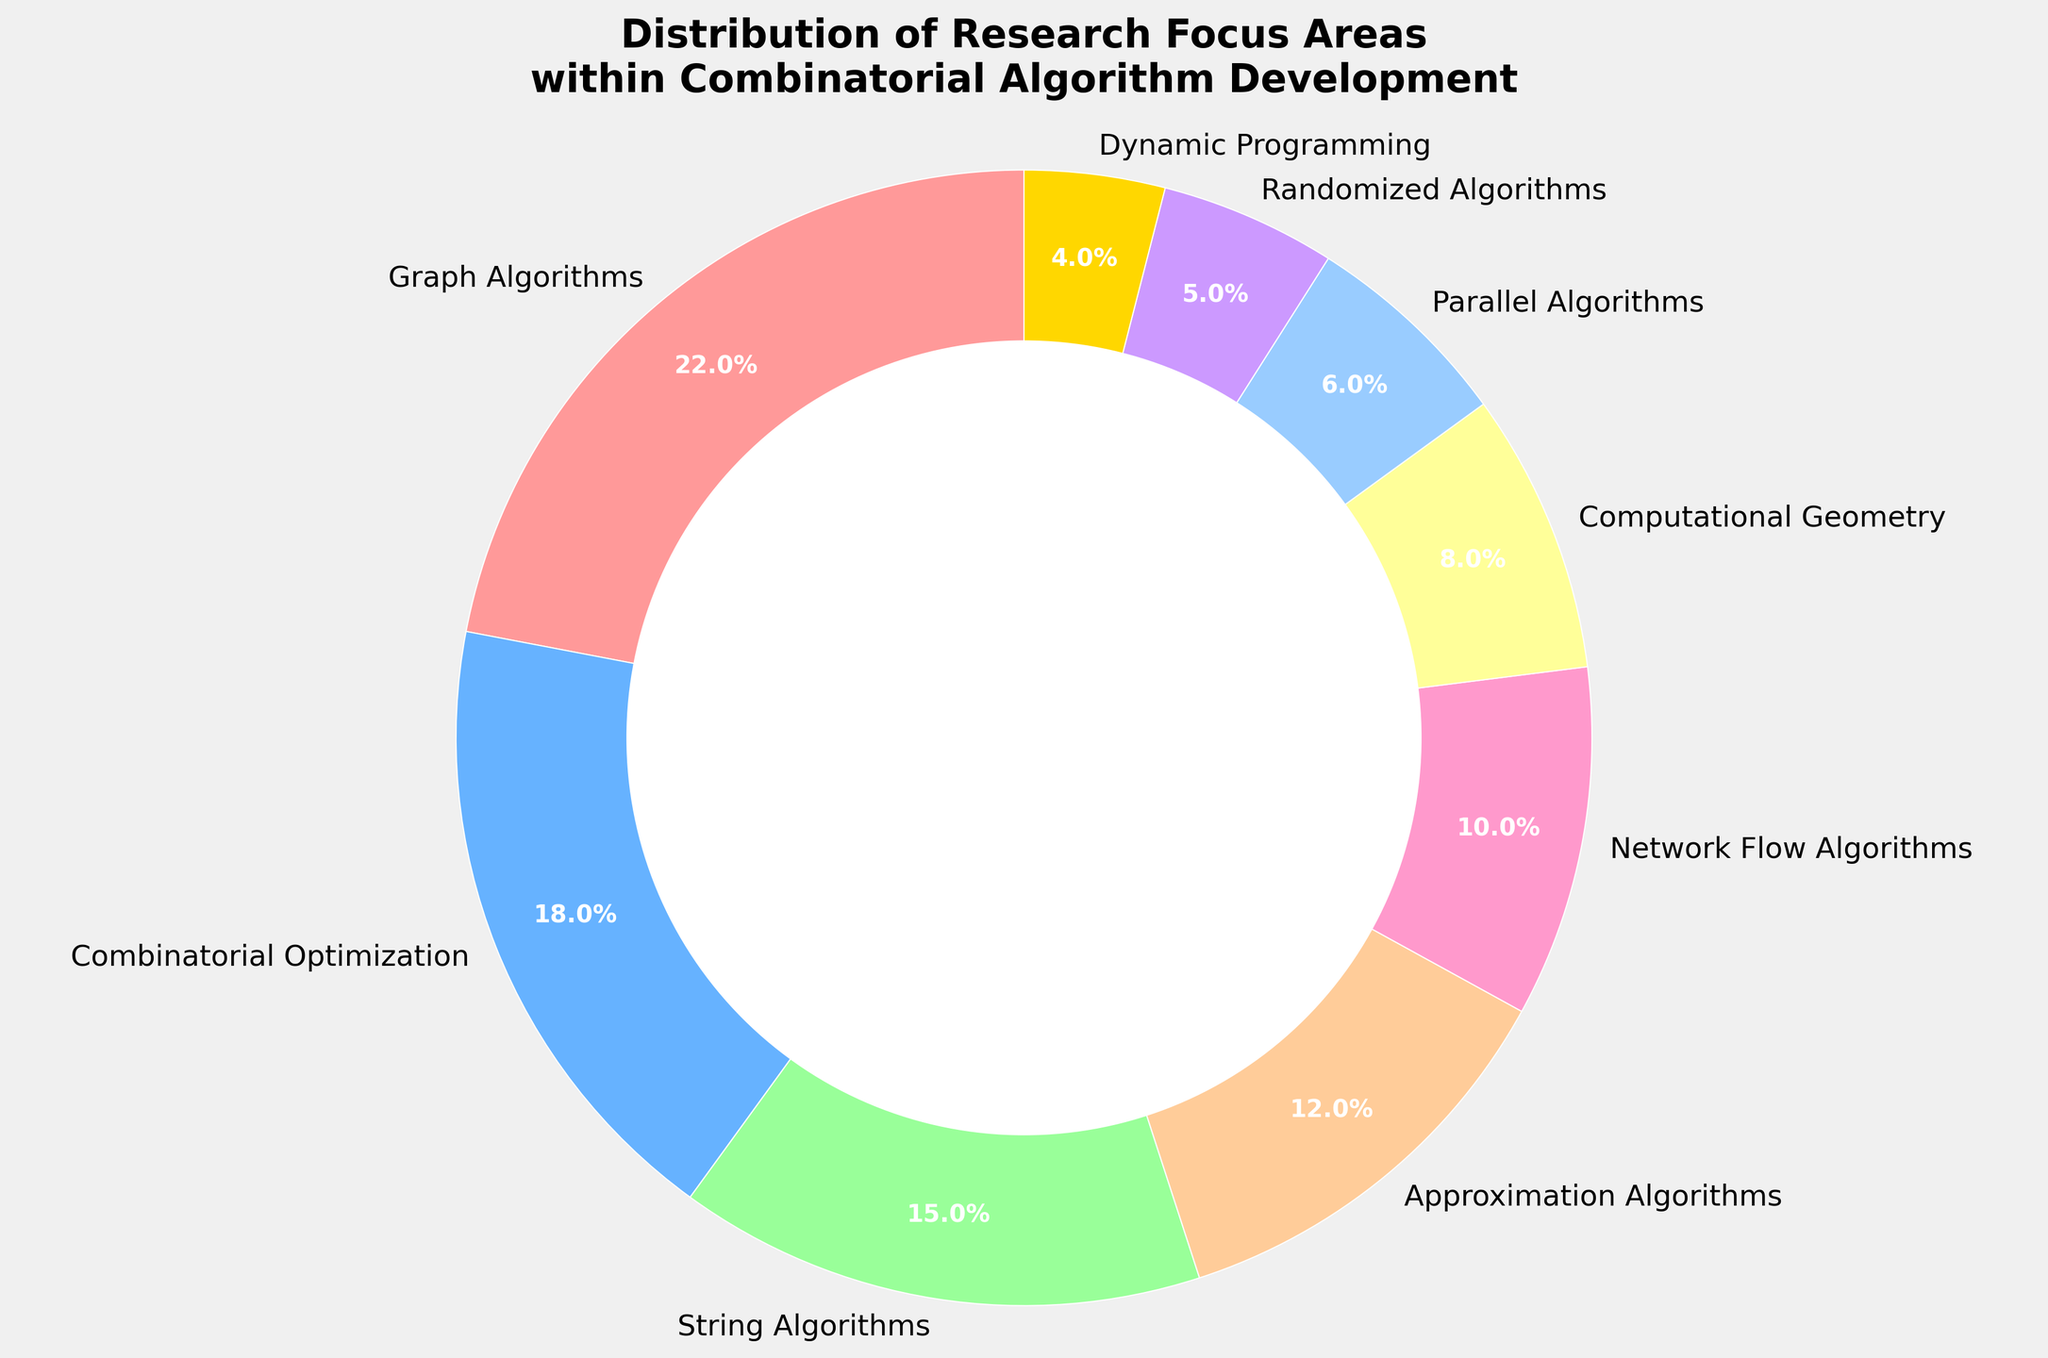Which research focus area has the highest percentage? To determine this, look for the largest wedge in the pie chart and refer to its label.
Answer: Graph Algorithms Which research focus area has the lowest percentage? Look for the smallest wedge in the pie chart and refer to its label.
Answer: Dynamic Programming What is the percentage difference between Graph Algorithms and Combinatorial Optimization? Find the percentages for both areas: Graph Algorithms (22%) and Combinatorial Optimization (18%). Subtract the second from the first: 22% - 18% = 4%.
Answer: 4% Which research focus area contributes less than 10% to the total distribution? Identify all areas with percentages below 10% in the pie chart.
Answer: Computational Geometry, Parallel Algorithms, Randomized Algorithms, Dynamic Programming What combined percentage do Approximation Algorithms and Network Flow Algorithms contribute? Find the percentages for both areas: Approximation Algorithms (12%) and Network Flow Algorithms (10%). Add them together: 12% + 10% = 22%.
Answer: 22% Are there more focus areas with percentages above or below 10%? Count the focus areas with percentages above 10% and those below 10%: Above 10% (Graph Algorithms, Combinatorial Optimization, String Algorithms, Approximation Algorithms) = 4. Below 10% (Network Flow Algorithms, Computational Geometry, Parallel Algorithms, Randomized Algorithms, Dynamic Programming) = 5. Compare the counts.
Answer: Below 10% Which focus area is represented by the light green color? Identify the wedge in light green and refer to its label in the pie chart.
Answer: String Algorithms Which focus areas contribute exactly 12% or more to the distribution? Select wedges with percentages of 12% or higher by referring to the labels and values: Graph Algorithms (22%), Combinatorial Optimization (18%), String Algorithms (15%), and Approximation Algorithms (12%).
Answer: Graph Algorithms, Combinatorial Optimization, String Algorithms, Approximation Algorithms What is the average percentage of the focus areas contributing less than 8% each? Identify the focus areas below 8%: Parallel Algorithms (6%), Randomized Algorithms (5%), Dynamic Programming (4%). Calculate the average: (6% + 5% + 4%) / 3 = 15% / 3 = 5%.
Answer: 5% How does the percentage of Parallel Algorithms compare to that of Computational Geometry? Identify the percentages: Parallel Algorithms (6%) and Computational Geometry (8%). Check if one is greater, equal, or less than the other: 6% < 8%.
Answer: Less than Computational Geometry 